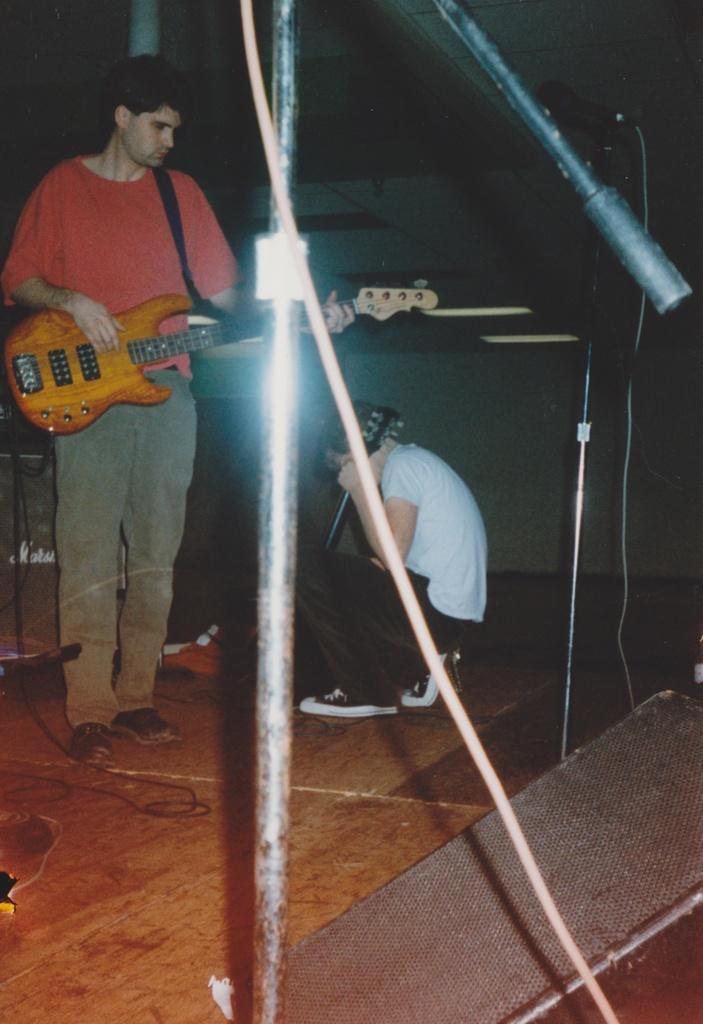How would you summarize this image in a sentence or two? In the center we can see man holding guitar,another man sitting and holding guitar. And back there is a wall. 